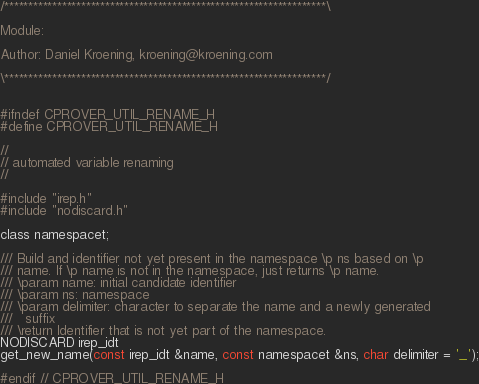<code> <loc_0><loc_0><loc_500><loc_500><_C_>/*******************************************************************\

Module:

Author: Daniel Kroening, kroening@kroening.com

\*******************************************************************/


#ifndef CPROVER_UTIL_RENAME_H
#define CPROVER_UTIL_RENAME_H

//
// automated variable renaming
//

#include "irep.h"
#include "nodiscard.h"

class namespacet;

/// Build and identifier not yet present in the namespace \p ns based on \p
/// name. If \p name is not in the namespace, just returns \p name.
/// \param name: initial candidate identifier
/// \param ns: namespace
/// \param delimiter: character to separate the name and a newly generated
///   suffix
/// \return Identifier that is not yet part of the namespace.
NODISCARD irep_idt
get_new_name(const irep_idt &name, const namespacet &ns, char delimiter = '_');

#endif // CPROVER_UTIL_RENAME_H
</code> 